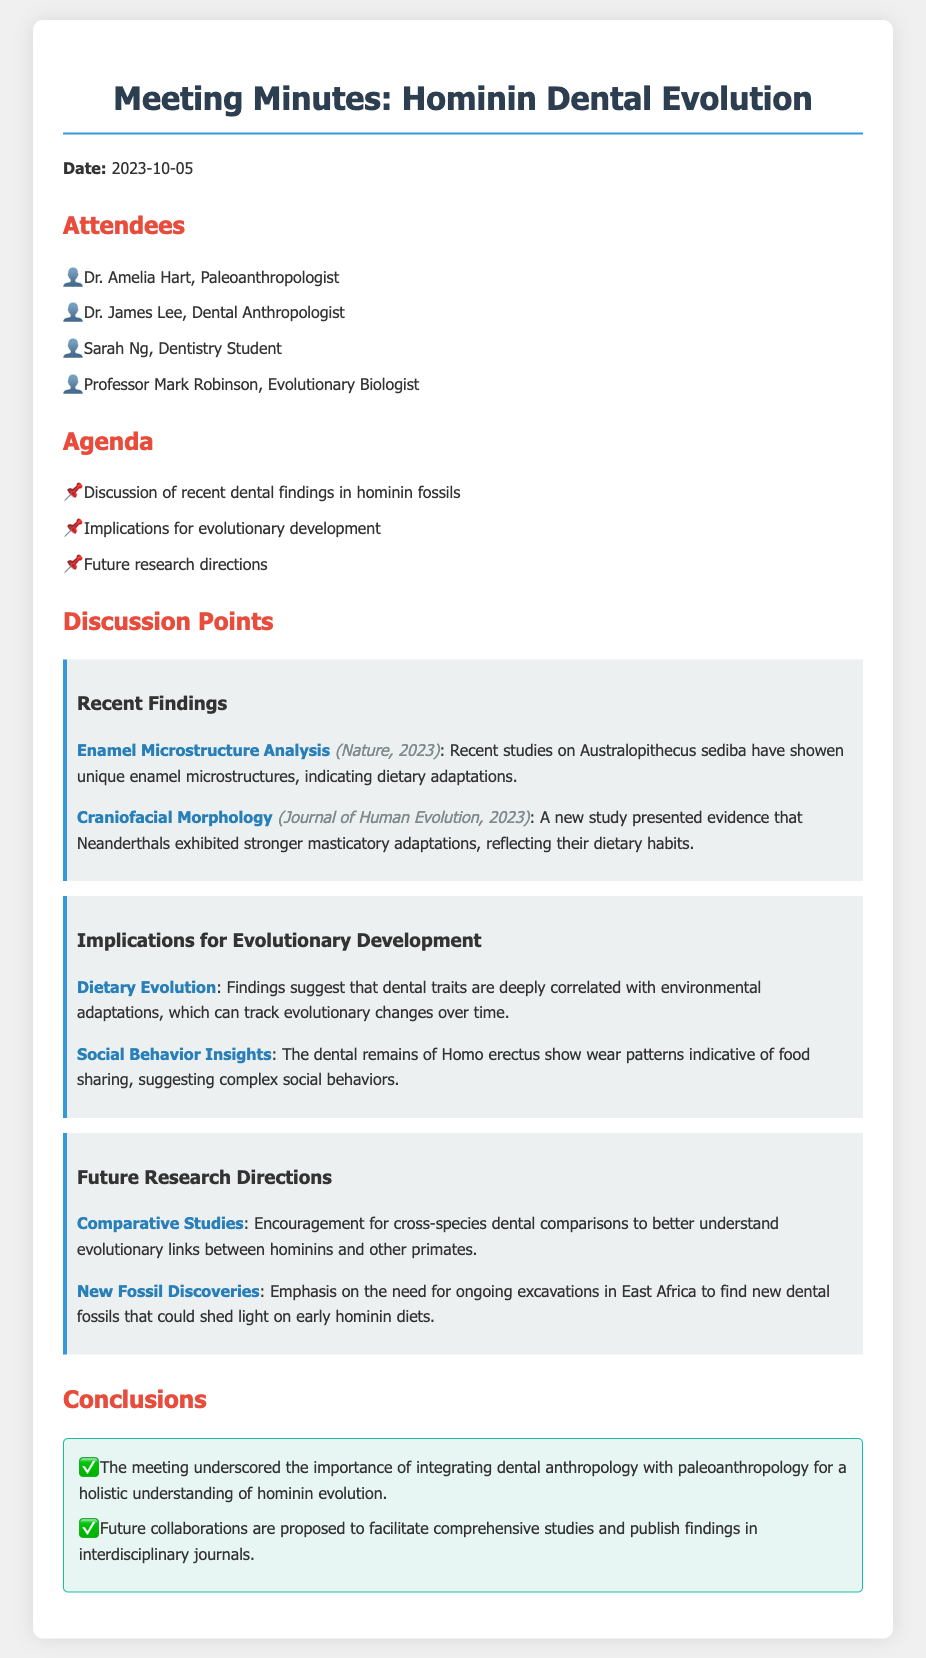what is the date of the meeting? The date of the meeting is stated at the beginning of the document.
Answer: 2023-10-05 who is a dental anthropologist present at the meeting? The attendees of the meeting are listed in the document, specifying each person's role.
Answer: Dr. James Lee what finding was reported in Nature, 2023? The document cites specific findings and their sources, including the studies from Nature.
Answer: Enamel Microstructure Analysis which species showed stronger masticatory adaptations? The discussion point about craniofacial morphology identifies the species related to this adaptation.
Answer: Neanderthals what implication does the dental remains of Homo erectus suggest? The document discusses implications derived from dental remains, focusing on social behaviors.
Answer: Food sharing what is a proposed future research direction? The document lists several future research directions related to the discussion points.
Answer: Comparative Studies 